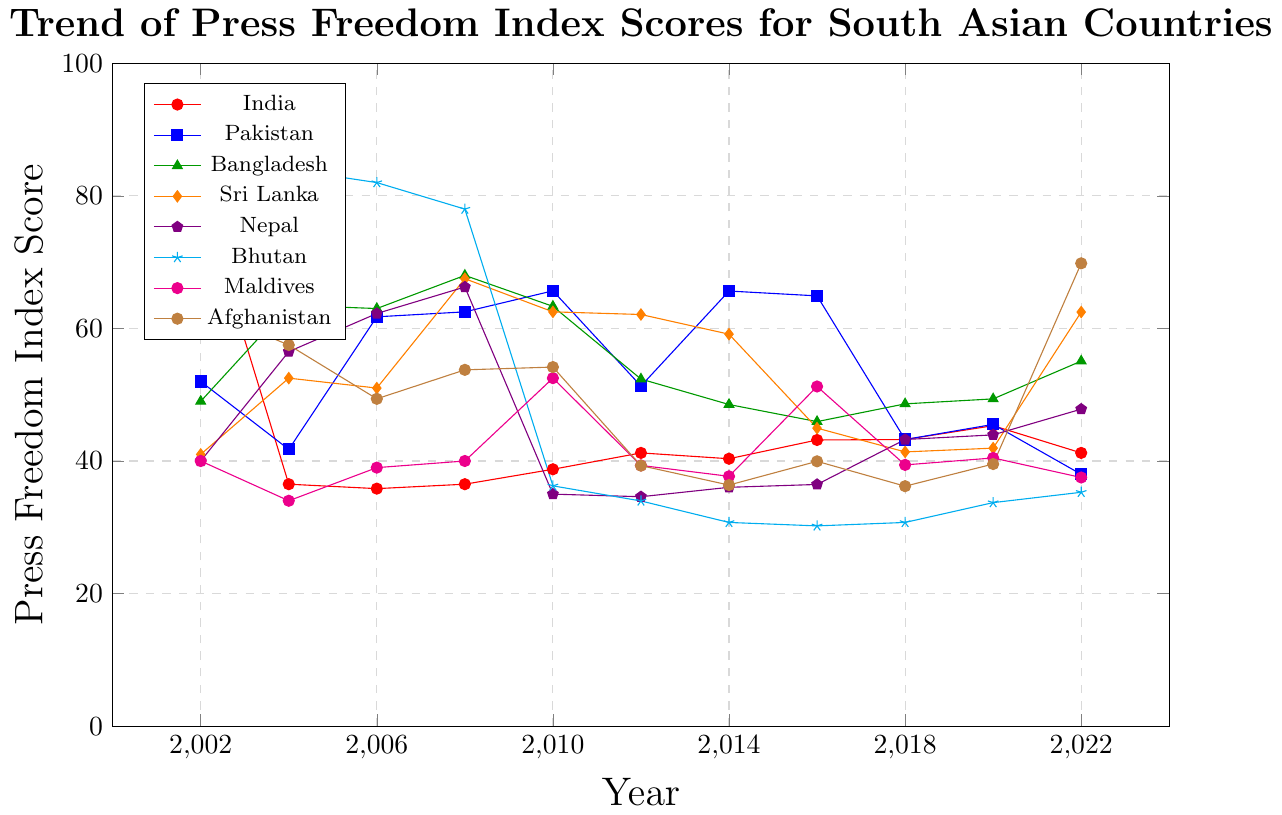Which country shows the most consistent improvement in Press Freedom Index scores from 2002 to 2022? Observe the trends for each country. Bhutan shows the most consistent improvement, decreasing from a high score of 93 in 2002 to 35.28 in 2022.
Answer: Bhutan Which country had the highest Press Freedom Index score in 2022? Compare all the final scores in 2022. Afghanistan had the highest score at 69.82.
Answer: Afghanistan Between 2010 and 2014, which country had the largest reduction in Press Freedom Index score? Calculate the difference for each country between 2010 and 2014. Pakistan had a reduction from 65.67 to 65.64, showing a minimal change, but Afghanistan had a significant reduction from 54.17 to 36.37 (a reduction of 17.8).
Answer: Afghanistan Which countries' Press Freedom Index scores crossed each other between 2002 and 2022? Look for intersections in the plot. India and Pakistan intersected between 2018 and 2020. Bangladesh and Nepal also show crossings around 2016 to 2018.
Answer: India and Pakistan; Bangladesh and Nepal What is the trend of India's Press Freedom Index scores over the past two decades? Follow the pattern of India's scores from 2002 to 2022. India's Press Freedom Index scores showed a general increasing trend with some fluctuations.
Answer: Increasing trend with fluctuations Which country experienced the sharpest decline in the Press Freedom Index score in a single year, and in which year did this occur? Look for the steepest slopes in the plot. Bhutan shows a sharp decline from around 78 in 2008 to 36.25 in 2010.
Answer: Bhutan, 2008 to 2010 By how much did Bangladesh's Press Freedom Index score change from 2002 to 2022? Subtract the 2002 score from the 2022 score for Bangladesh. The change is 55.07 - 49 = 6.07.
Answer: 6.07 Between 2012 and 2016, which country shows the most improvement in Press Freedom Index scores? Compare the score differences for each country. Bangladesh improved from 52.36 to 45.94, a change of 6.42. Nepal's score changed slightly from 34.61 to 36.46, showing an increase. Bhutan improved from 33.97 to 30.21, a change of 3.76. Other countries like India, Pakistan, etc., did not show greater improvement.
Answer: Bangladesh In the year 2016, which country had the lowest Press Freedom Index score and which one had the highest? Compare the 2016 scores for all countries. Bhutan had the lowest score at 30.21, while Pakistan had the highest at 64.91.
Answer: Lowest - Bhutan; Highest - Pakistan Considering the data from 2002 to 2022, which country has shown the biggest overall improvement? Compare the scores from 2002 to 2022 for each country and calculate the change. Bhutan improved from a score of 93 in 2002 to 35.28 in 2022, showing an improvement of 57.72, which is the highest improvement.
Answer: Bhutan 